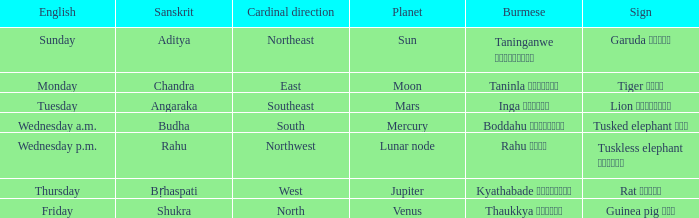What is the Burmese term for Thursday? Kyathabade ကြာသပတေး. 